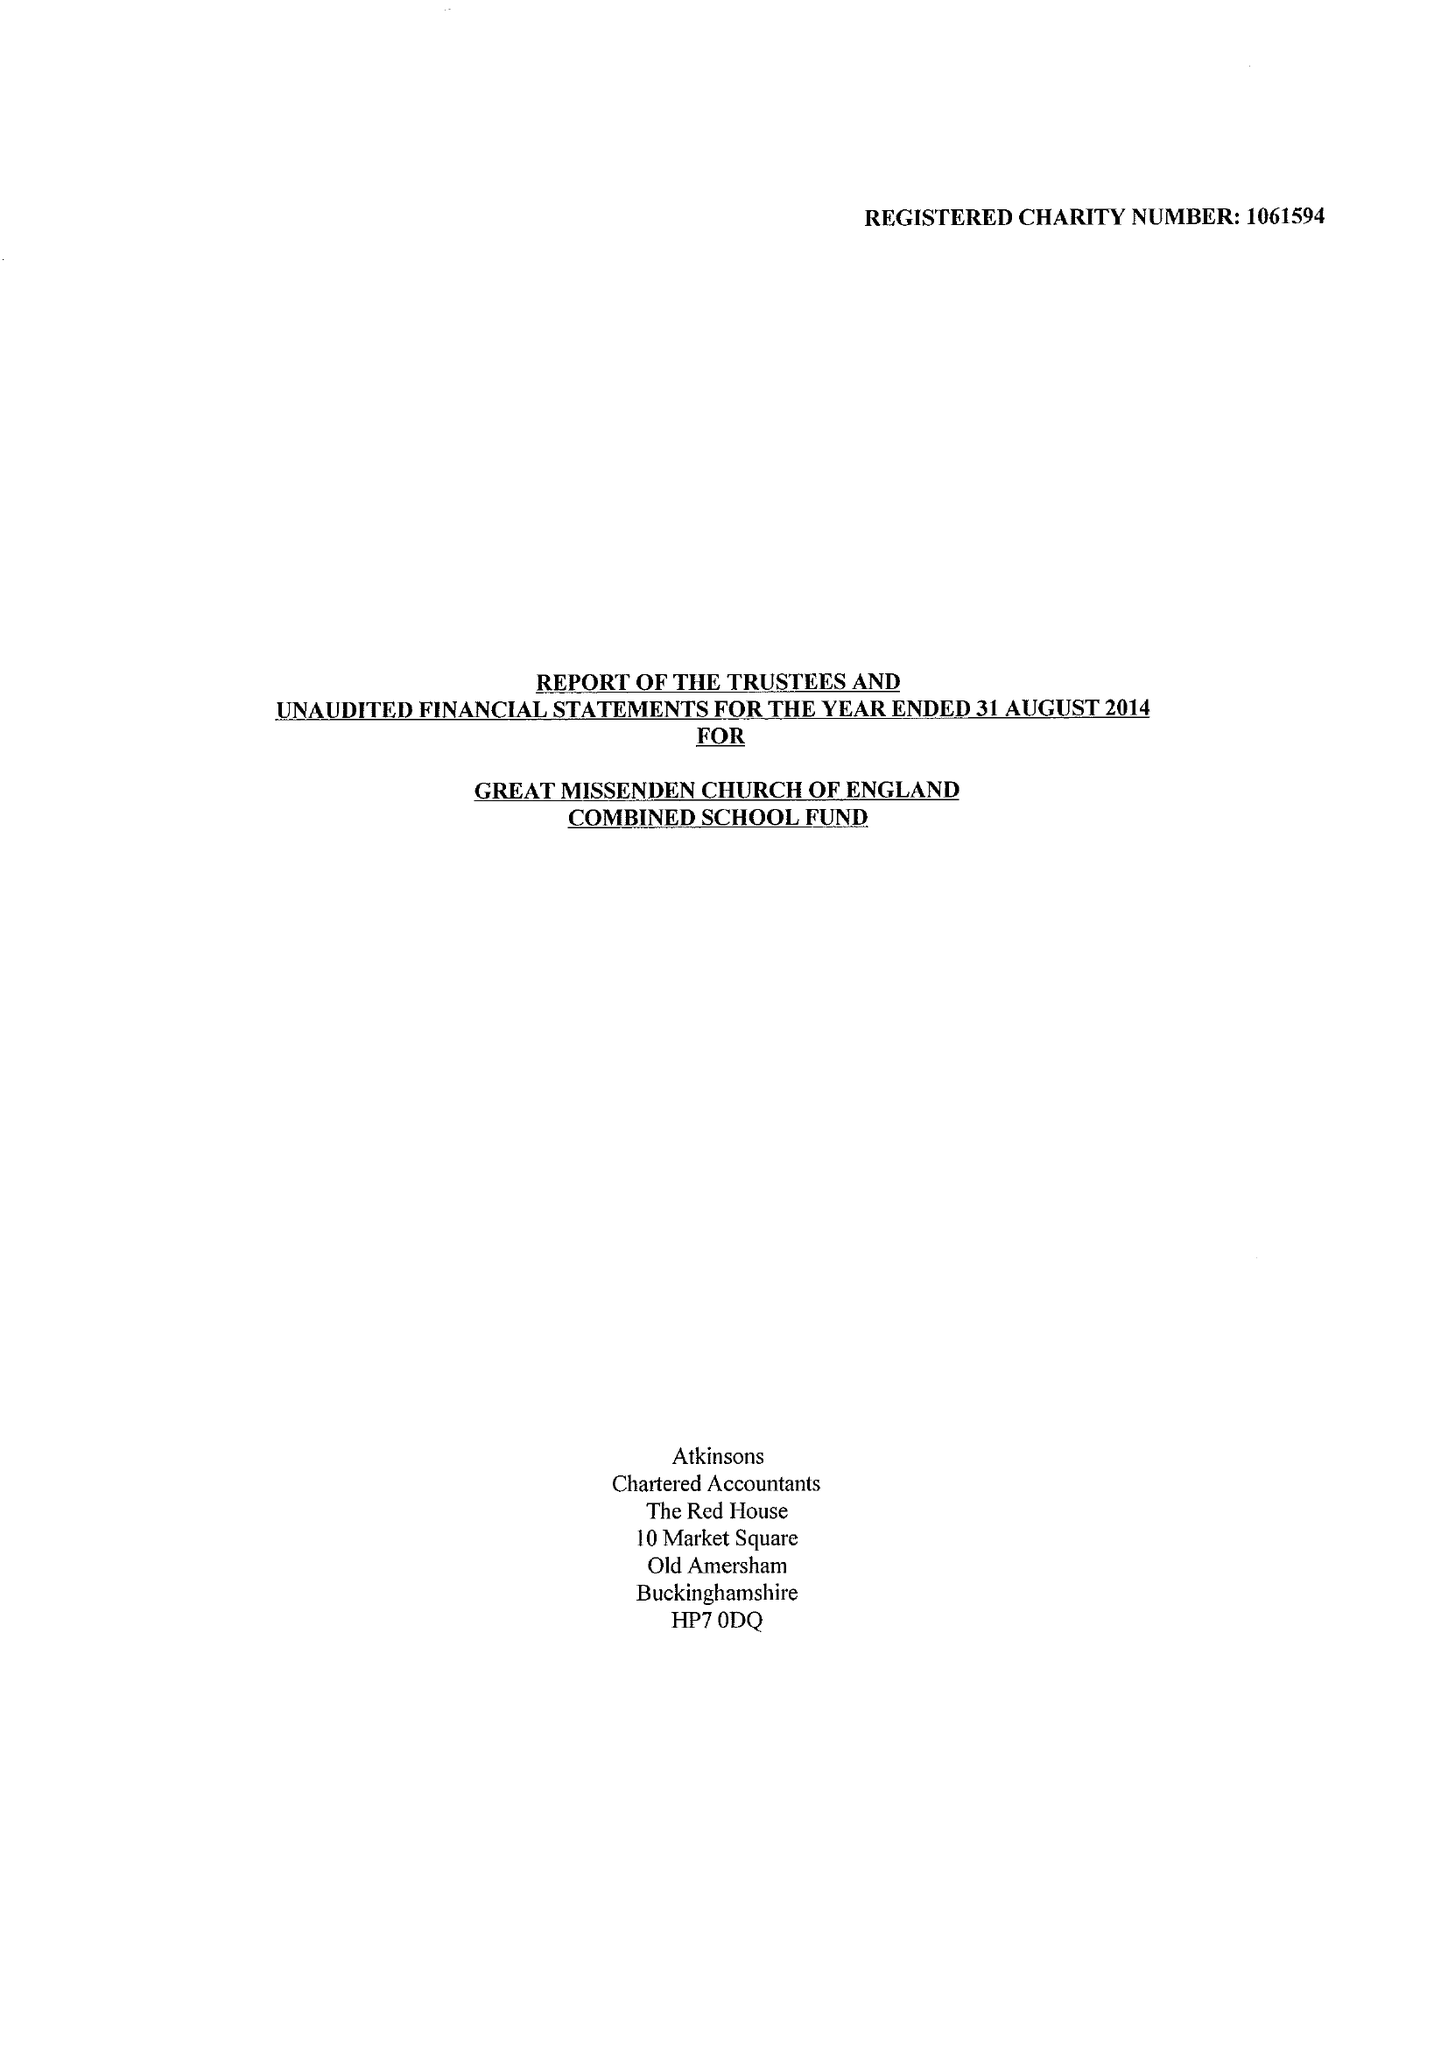What is the value for the income_annually_in_british_pounds?
Answer the question using a single word or phrase. 337664.00 